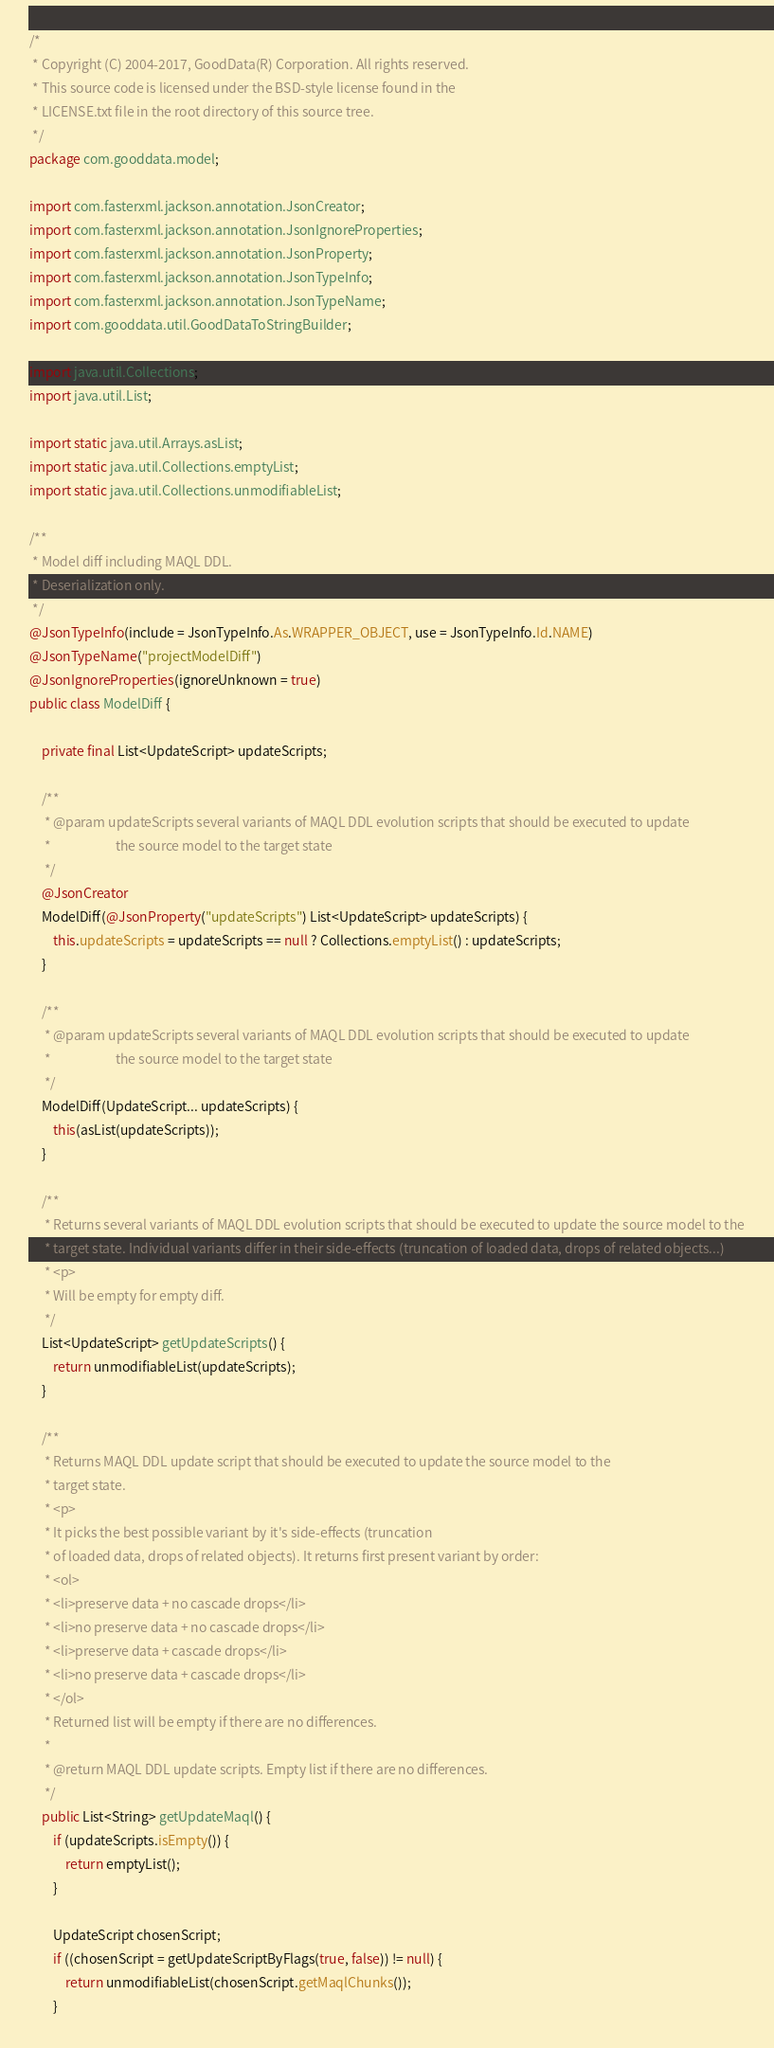<code> <loc_0><loc_0><loc_500><loc_500><_Java_>/*
 * Copyright (C) 2004-2017, GoodData(R) Corporation. All rights reserved.
 * This source code is licensed under the BSD-style license found in the
 * LICENSE.txt file in the root directory of this source tree.
 */
package com.gooddata.model;

import com.fasterxml.jackson.annotation.JsonCreator;
import com.fasterxml.jackson.annotation.JsonIgnoreProperties;
import com.fasterxml.jackson.annotation.JsonProperty;
import com.fasterxml.jackson.annotation.JsonTypeInfo;
import com.fasterxml.jackson.annotation.JsonTypeName;
import com.gooddata.util.GoodDataToStringBuilder;

import java.util.Collections;
import java.util.List;

import static java.util.Arrays.asList;
import static java.util.Collections.emptyList;
import static java.util.Collections.unmodifiableList;

/**
 * Model diff including MAQL DDL.
 * Deserialization only.
 */
@JsonTypeInfo(include = JsonTypeInfo.As.WRAPPER_OBJECT, use = JsonTypeInfo.Id.NAME)
@JsonTypeName("projectModelDiff")
@JsonIgnoreProperties(ignoreUnknown = true)
public class ModelDiff {

    private final List<UpdateScript> updateScripts;

    /**
     * @param updateScripts several variants of MAQL DDL evolution scripts that should be executed to update
     *                      the source model to the target state
     */
    @JsonCreator
    ModelDiff(@JsonProperty("updateScripts") List<UpdateScript> updateScripts) {
        this.updateScripts = updateScripts == null ? Collections.emptyList() : updateScripts;
    }

    /**
     * @param updateScripts several variants of MAQL DDL evolution scripts that should be executed to update
     *                      the source model to the target state
     */
    ModelDiff(UpdateScript... updateScripts) {
        this(asList(updateScripts));
    }

    /**
     * Returns several variants of MAQL DDL evolution scripts that should be executed to update the source model to the
     * target state. Individual variants differ in their side-effects (truncation of loaded data, drops of related objects...)
     * <p>
     * Will be empty for empty diff.
     */
    List<UpdateScript> getUpdateScripts() {
        return unmodifiableList(updateScripts);
    }

    /**
     * Returns MAQL DDL update script that should be executed to update the source model to the
     * target state.
     * <p>
     * It picks the best possible variant by it's side-effects (truncation
     * of loaded data, drops of related objects). It returns first present variant by order:
     * <ol>
     * <li>preserve data + no cascade drops</li>
     * <li>no preserve data + no cascade drops</li>
     * <li>preserve data + cascade drops</li>
     * <li>no preserve data + cascade drops</li>
     * </ol>
     * Returned list will be empty if there are no differences.
     *
     * @return MAQL DDL update scripts. Empty list if there are no differences.
     */
    public List<String> getUpdateMaql() {
        if (updateScripts.isEmpty()) {
            return emptyList();
        }

        UpdateScript chosenScript;
        if ((chosenScript = getUpdateScriptByFlags(true, false)) != null) {
            return unmodifiableList(chosenScript.getMaqlChunks());
        }</code> 